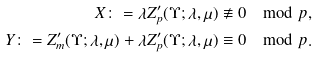Convert formula to latex. <formula><loc_0><loc_0><loc_500><loc_500>X \colon = \lambda Z ^ { \prime } _ { p } ( \Upsilon ; \lambda , \mu ) \not \equiv 0 \mod p , \\ Y \colon = Z ^ { \prime } _ { m } ( \Upsilon ; \lambda , \mu ) + \lambda Z ^ { \prime } _ { p } ( \Upsilon ; \lambda , \mu ) \equiv 0 \mod p .</formula> 